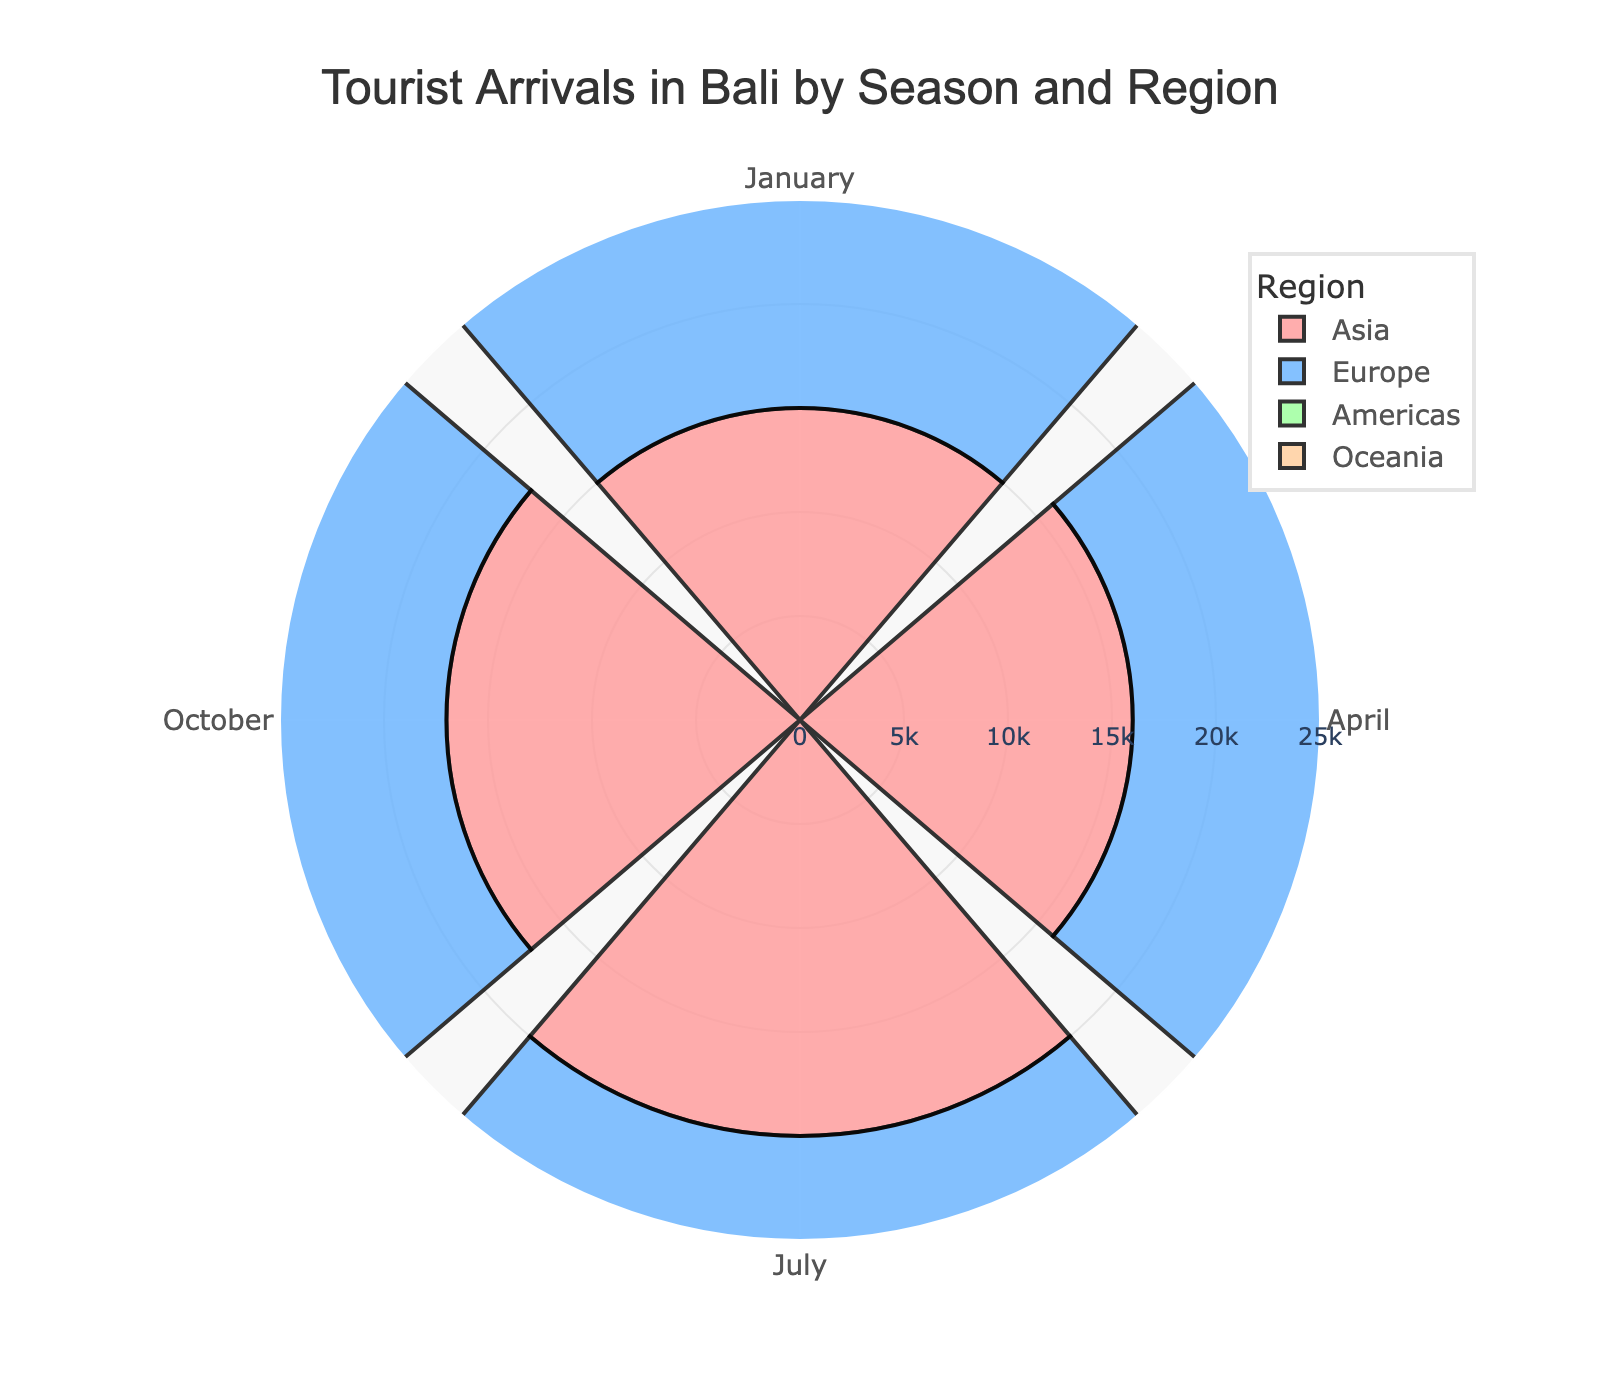What’s the title of the rose chart? The title is located at the top center of the chart. It reads: "Tourist Arrivals in Bali by Season and Region".
Answer: Tourist Arrivals in Bali by Season and Region How many tourist arrival groups are represented? By looking at the legend on the right side of the chart, we can count the distinct color-coded groups: Asia, Europe, Americas, and Oceania.
Answer: 4 Which month saw the highest tourist arrivals from Asia? By observing the segments representing Asia in each month, the longest bar is in July, indicating the highest value.
Answer: July What is the total number of tourists arriving from Europe in the months of January and April? We find the values for Europe in January (12000) and April (11000) and sum them up: 12000 + 11000.
Answer: 23000 Which region has the lowest tourist arrivals in April? By comparing the lengths of the bars in April, Americas (no value is given, hence 0) is missing, indicating it has the lowest arrivals.
Answer: Americas Among the given months, in which month does Oceania have the highest tourist arrivals? By inspecting the bars for Oceania across the months, the longest bar for Oceania is in October with a value of 13000.
Answer: October How do the tourist arrivals from Americas in July compare to those in January? By comparing the height of the bars, the Arrival value in July is 15000, which is higher than in January at 8000.
Answer: July is higher What is the average tourist arrivals from Asia across all the given months? Summing up the values for Asia (15000 + 16000 + 20000 + 17000) and dividing by 4, we get (15000 + 16000 + 20000 + 17000) / 4.
Answer: 17000 Which group has a higher arrival number in January, Asia or Europe? By comparing the heights of the bars, Asia has 15000 and Europe has 12000 in January, so Asia has a higher arrival number.
Answer: Asia 